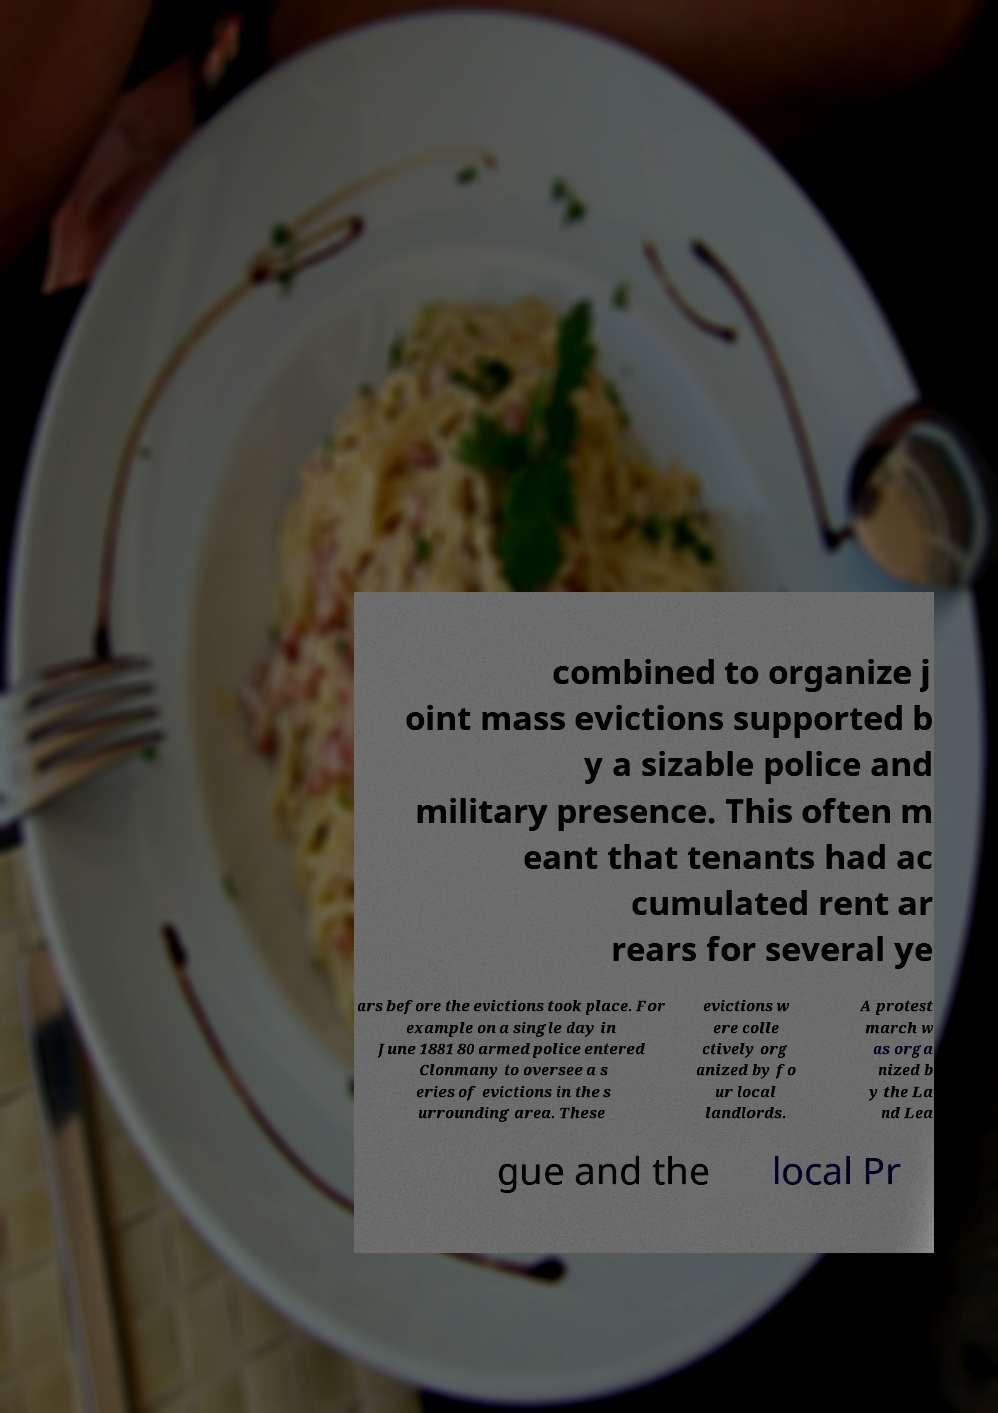Could you assist in decoding the text presented in this image and type it out clearly? combined to organize j oint mass evictions supported b y a sizable police and military presence. This often m eant that tenants had ac cumulated rent ar rears for several ye ars before the evictions took place. For example on a single day in June 1881 80 armed police entered Clonmany to oversee a s eries of evictions in the s urrounding area. These evictions w ere colle ctively org anized by fo ur local landlords. A protest march w as orga nized b y the La nd Lea gue and the local Pr 